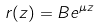Convert formula to latex. <formula><loc_0><loc_0><loc_500><loc_500>r ( z ) = B e ^ { \mu z }</formula> 